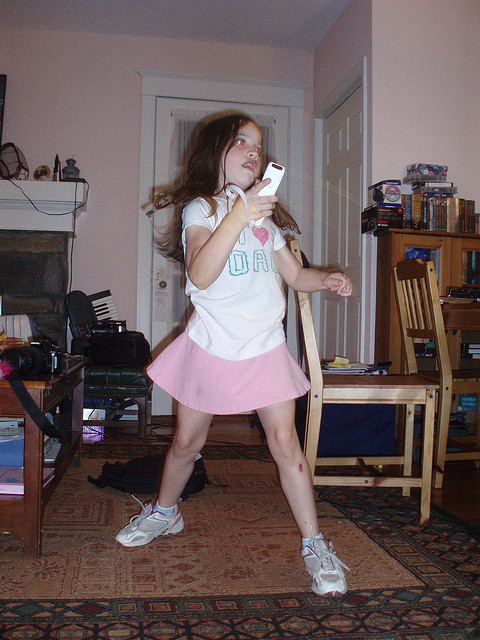Please transcribe the text information in this image. DA 